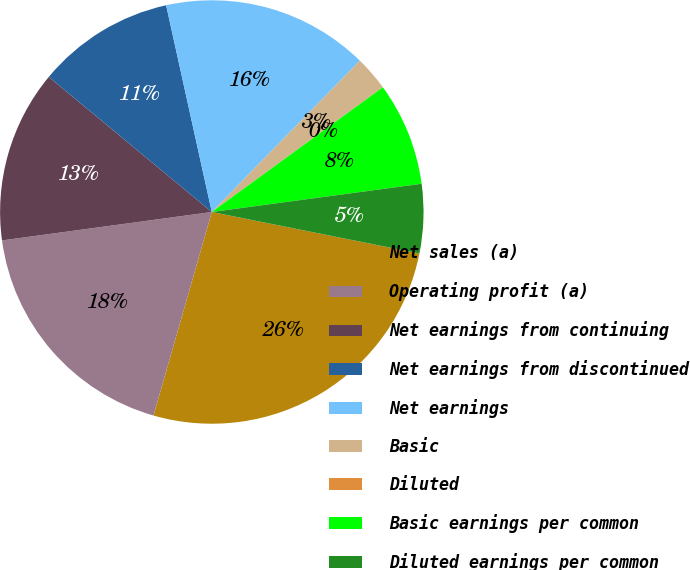<chart> <loc_0><loc_0><loc_500><loc_500><pie_chart><fcel>Net sales (a)<fcel>Operating profit (a)<fcel>Net earnings from continuing<fcel>Net earnings from discontinued<fcel>Net earnings<fcel>Basic<fcel>Diluted<fcel>Basic earnings per common<fcel>Diluted earnings per common<nl><fcel>26.31%<fcel>18.42%<fcel>13.16%<fcel>10.53%<fcel>15.79%<fcel>2.64%<fcel>0.01%<fcel>7.9%<fcel>5.27%<nl></chart> 